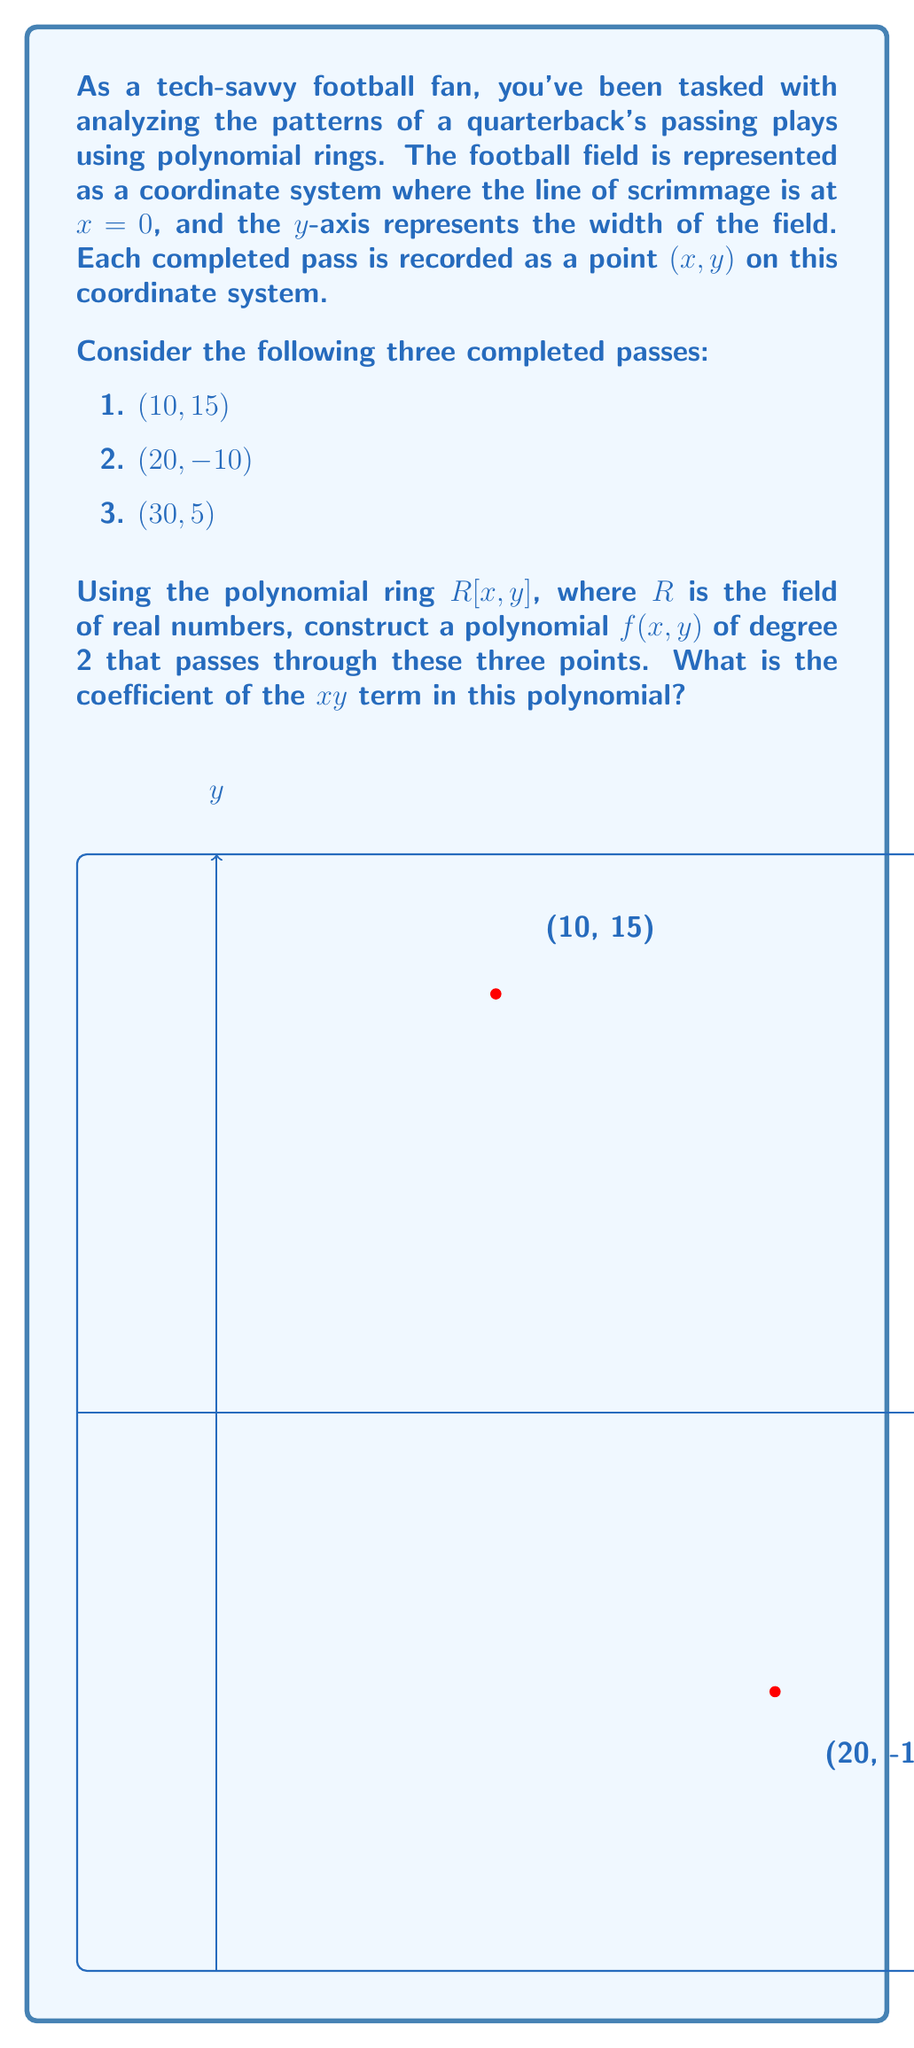Teach me how to tackle this problem. Let's approach this step-by-step:

1) We're looking for a polynomial of the form:
   $$f(x,y) = ax^2 + bxy + cy^2 + dx + ey + f$$

2) We need to solve a system of equations using the given points:
   $$(10, 15): 100a + 150b + 225c + 10d + 15e + f = 0$$
   $$(20, -10): 400a - 200b + 100c + 20d - 10e + f = 0$$
   $$(30, 5): 900a + 150b + 25c + 30d + 5e + f = 0$$

3) We have 3 equations and 6 unknowns. To simplify, let's set $a = 1$, $c = 0$, and $f = 0$. This gives us:

   $$150b + 10d + 15e = -100$$
   $$-200b + 20d - 10e = -400$$
   $$150b + 30d + 5e = -900$$

4) Solving this system of equations (you can use elimination or matrix methods), we get:
   $$b = -\frac{1}{3}, d = -15, e = 10$$

5) Therefore, our polynomial is:
   $$f(x,y) = x^2 - \frac{1}{3}xy - 15x + 10y$$

6) The coefficient of the xy term is $-\frac{1}{3}$.
Answer: $-\frac{1}{3}$ 